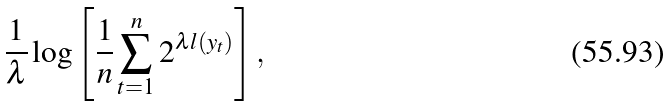Convert formula to latex. <formula><loc_0><loc_0><loc_500><loc_500>\frac { 1 } { \lambda } \log \left [ \frac { 1 } { n } \sum _ { t = 1 } ^ { n } 2 ^ { \lambda l ( y _ { t } ) } \right ] ,</formula> 